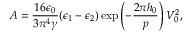Convert formula to latex. <formula><loc_0><loc_0><loc_500><loc_500>A = \frac { 1 6 \epsilon _ { 0 } } { 3 \pi ^ { 4 } \gamma } ( \epsilon _ { 1 } - \epsilon _ { 2 } ) \exp \left ( - \frac { 2 \pi h _ { 0 } } { p } \right ) V _ { 0 } ^ { 2 } ,</formula> 